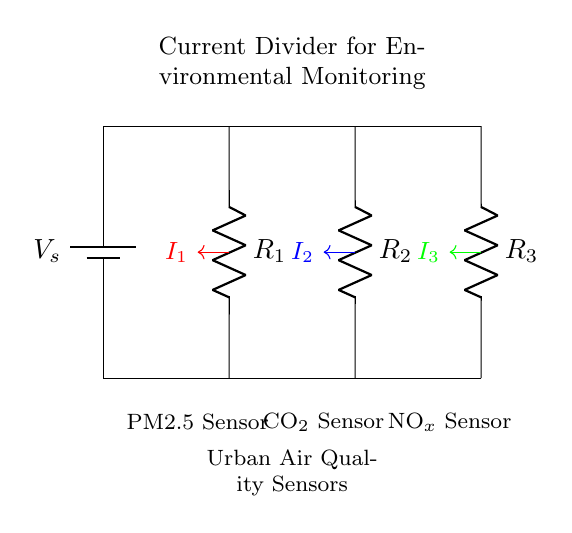What is the supply voltage in this circuit? The supply voltage is indicated by the battery symbol, and is labeled as V_s.
Answer: V_s What are the resistances in this circuit? The circuit diagram shows three resistors labeled as R_1, R_2, and R_3.
Answer: R_1, R_2, R_3 How many sensors are connected in this current divider circuit? The circuit illustrates three sensors connected in parallel, corresponding to the resistors.
Answer: Three Which sensor corresponds to R_1? The sensor connected through R_1 is labeled as the PM2.5 Sensor, which measures particulate matter.
Answer: PM2.5 Sensor If R_1 is 2 ohms, R_2 is 4 ohms, and R_3 is 6 ohms, what is the relationship between the currents flowing through the resistors? In a current divider, the current is inversely proportional to the resistance. Thus, I_1 will be the greatest and I_3 will be the smallest.
Answer: I_1 > I_2 > I_3 Which sensor would receive the least current? Based on the current divider principle, the sensor connected to the highest resistance, in this case, R_3, receives the least current.
Answer: NOx Sensor 